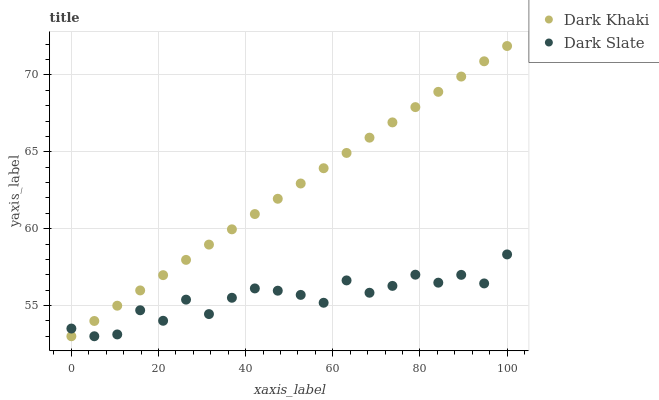Does Dark Slate have the minimum area under the curve?
Answer yes or no. Yes. Does Dark Khaki have the maximum area under the curve?
Answer yes or no. Yes. Does Dark Slate have the maximum area under the curve?
Answer yes or no. No. Is Dark Khaki the smoothest?
Answer yes or no. Yes. Is Dark Slate the roughest?
Answer yes or no. Yes. Is Dark Slate the smoothest?
Answer yes or no. No. Does Dark Khaki have the lowest value?
Answer yes or no. Yes. Does Dark Khaki have the highest value?
Answer yes or no. Yes. Does Dark Slate have the highest value?
Answer yes or no. No. Does Dark Slate intersect Dark Khaki?
Answer yes or no. Yes. Is Dark Slate less than Dark Khaki?
Answer yes or no. No. Is Dark Slate greater than Dark Khaki?
Answer yes or no. No. 